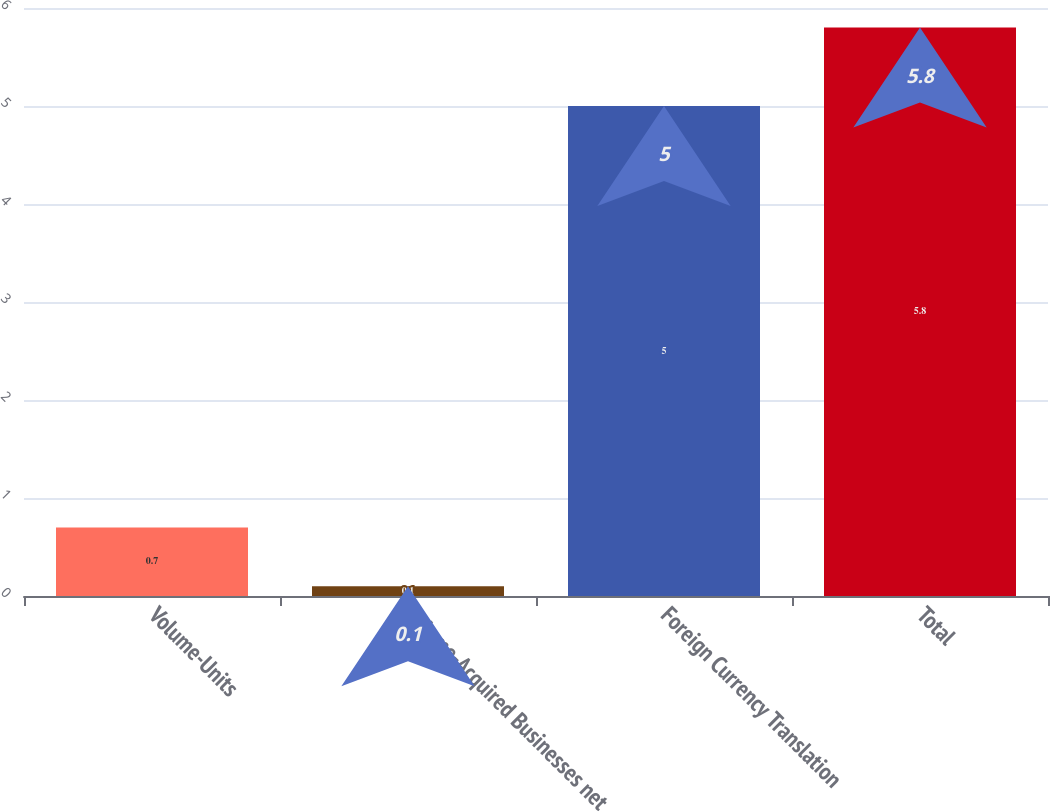Convert chart. <chart><loc_0><loc_0><loc_500><loc_500><bar_chart><fcel>Volume-Units<fcel>Volume-Acquired Businesses net<fcel>Foreign Currency Translation<fcel>Total<nl><fcel>0.7<fcel>0.1<fcel>5<fcel>5.8<nl></chart> 